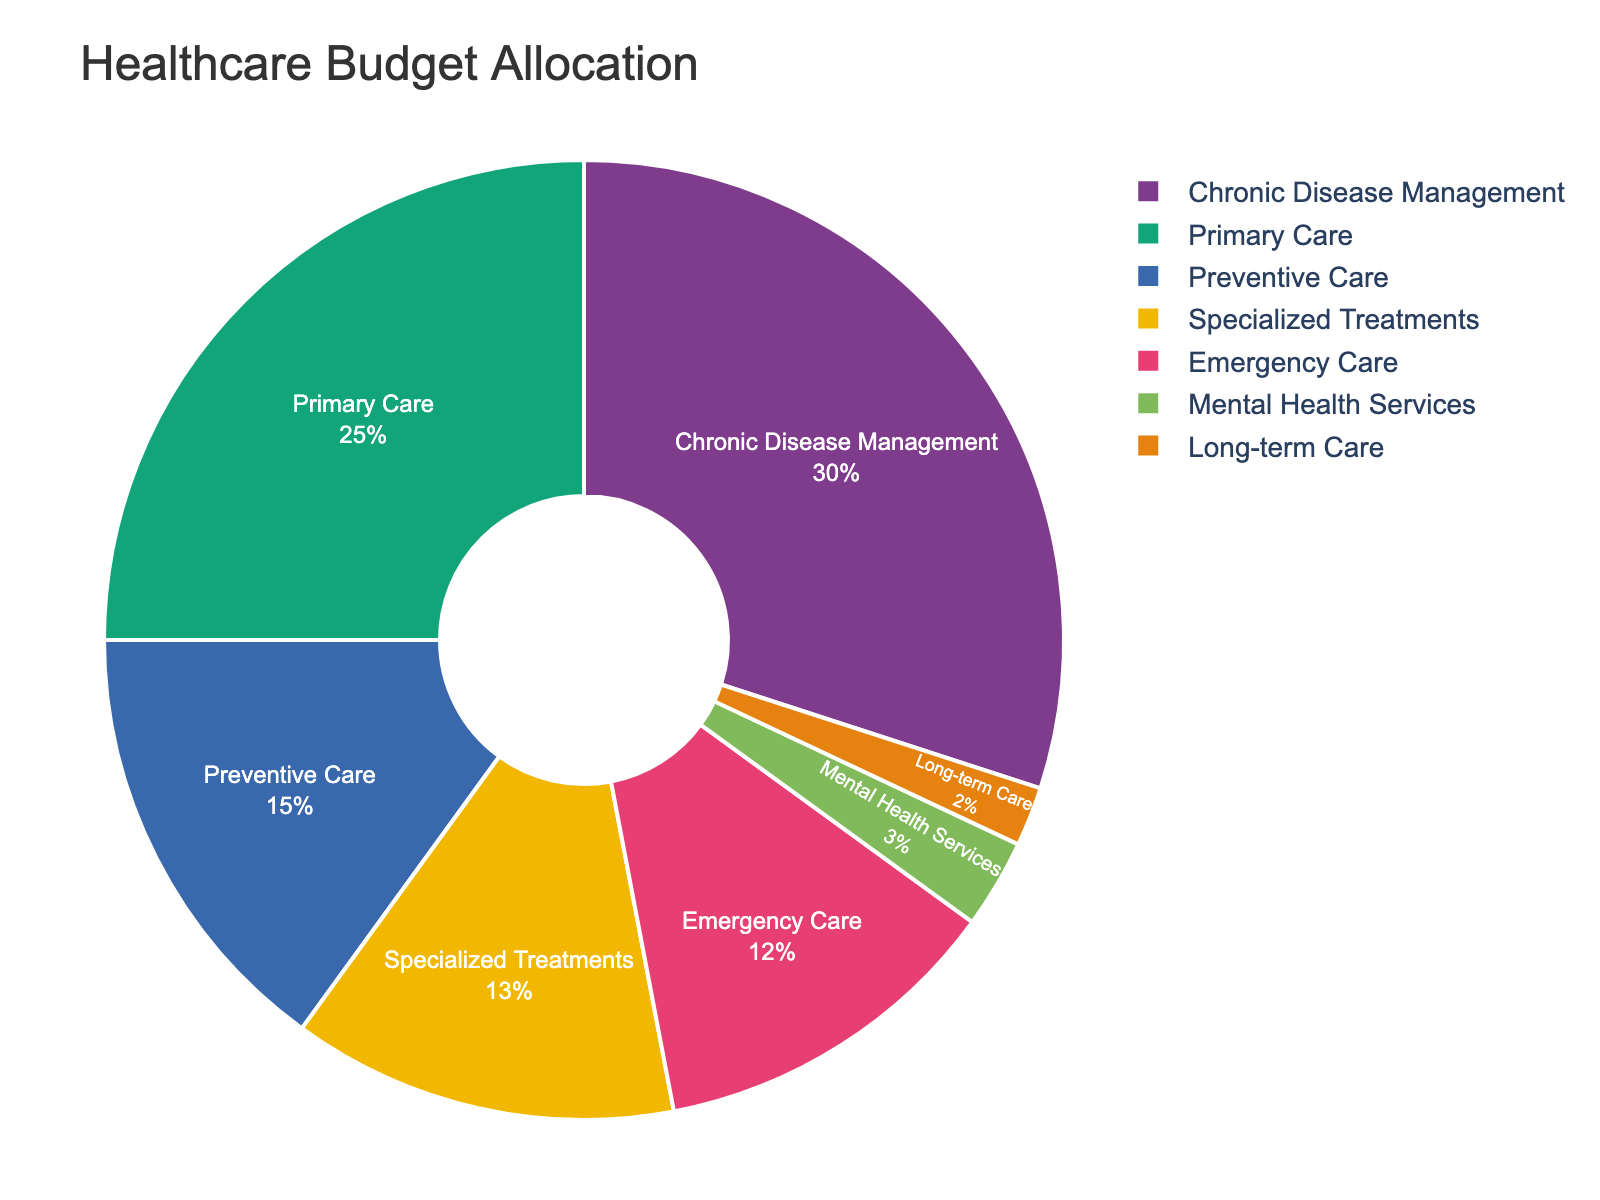What is the proportion of the healthcare budget allocated to Preventive Care? Look at the segment labeled "Preventive Care" on the pie chart. The percentage indicated is 15%.
Answer: 15% Which category has the highest allocation in the healthcare budget? Identify the segment with the largest area and percentage. The "Chronic Disease Management" category represents 30%, which is the highest allocated proportion.
Answer: Chronic Disease Management How much more of the budget is allocated to Primary Care compared to Emergency Care? Identify the percentages for both Primary Care (25%) and Emergency Care (12%) and calculate the difference: 25% - 12% = 13%.
Answer: 13% What percentage of the healthcare budget is allocated to categories other than Chronic Disease Management? Subtract the percentage of Chronic Disease Management from 100%: 100% - 30% = 70%.
Answer: 70% Is the budget allocated to Mental Health Services greater than that of Long-term Care? Compare the percentages for Mental Health Services (3%) and Long-term Care (2%). 3% is greater than 2%.
Answer: Yes What is the total budget allocation for categories related to acute (short-term) healthcare needs (Emergency Care and Specialized Treatments)? Add the percentages for Emergency Care (12%) and Specialized Treatments (13%): 12% + 13% = 25%.
Answer: 25% How does the allocation to Specialized Treatments compare to Preventive Care? Compare the percentages for Specialized Treatments (13%) and Preventive Care (15%). 13% is less than 15%.
Answer: Less What is the combined percentage of the budget allocated to categories focused on long-term health improvement (Preventive Care, Primary Care, Chronic Disease Management, and Mental Health Services)? Add the percentages of Preventive Care (15%), Primary Care (25%), Chronic Disease Management (30%), and Mental Health Services (3%): 15% + 25% + 30% + 3% = 73%.
Answer: 73% Is the budget allocation for Long-term Care and Mental Health Services together more than that for Emergency Care? Add the percentages for Long-term Care (2%) and Mental Health Services (3%): 2% + 3% = 5%, and compare it to Emergency Care (12%). 5% is less than 12%.
Answer: No What is the budget ratio of Emergency Care to Specialized Treatments? Divide the percentage allocated to Emergency Care (12%) by the percentage allocated to Specialized Treatments (13%): 12 / 13 ≈ 0.923.
Answer: Approximately 0.923 